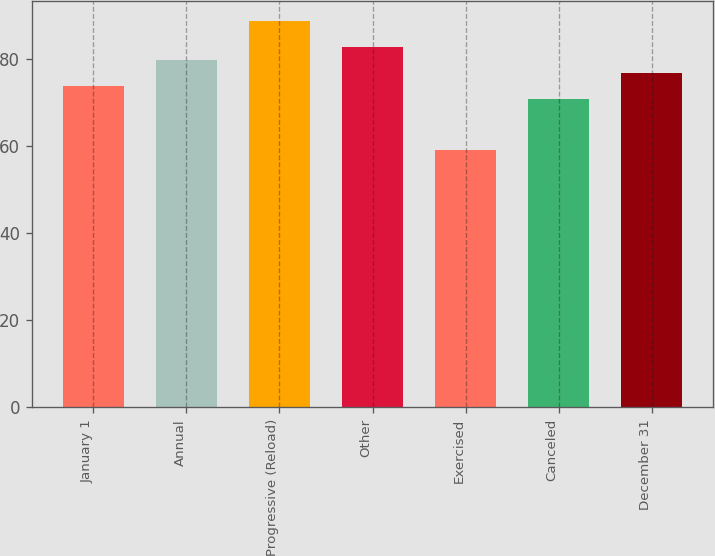Convert chart to OTSL. <chart><loc_0><loc_0><loc_500><loc_500><bar_chart><fcel>January 1<fcel>Annual<fcel>Progressive (Reload)<fcel>Other<fcel>Exercised<fcel>Canceled<fcel>December 31<nl><fcel>73.72<fcel>79.64<fcel>88.67<fcel>82.6<fcel>59.11<fcel>70.76<fcel>76.68<nl></chart> 